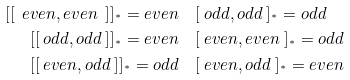Convert formula to latex. <formula><loc_0><loc_0><loc_500><loc_500>[ [ \ e v e n , e v e n \ ] ] _ { ^ { * } } = e v e n & \quad [ \ o d d , o d d \ ] _ { ^ { * } } = o d d \\ [ [ \ o d d , o d d \ ] ] _ { ^ { * } } = e v e n & \quad [ \ e v e n , e v e n \ ] _ { ^ { * } } = o d d \\ [ [ \ e v e n , o d d \ ] ] _ { ^ { * } } = o d d & \quad [ \ e v e n , o d d \ ] _ { ^ { * } } = e v e n</formula> 